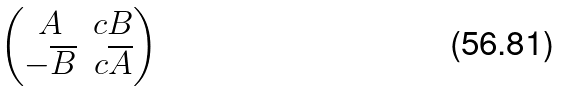<formula> <loc_0><loc_0><loc_500><loc_500>\begin{pmatrix} A & c B \\ - \overline { B } & c \overline { A } \end{pmatrix}</formula> 